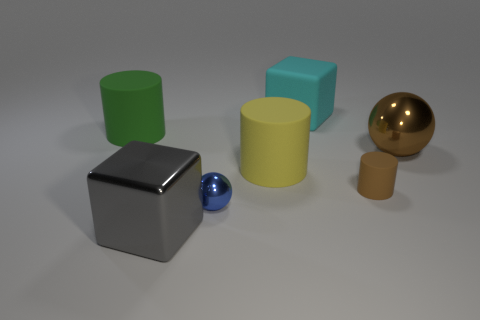Is the number of big cylinders that are in front of the tiny matte thing less than the number of tiny red objects?
Provide a short and direct response. No. Do the tiny matte object and the big shiny sphere have the same color?
Give a very brief answer. Yes. What is the size of the brown matte cylinder?
Offer a terse response. Small. How many large objects have the same color as the small cylinder?
Your answer should be very brief. 1. Are there any rubber cylinders on the right side of the large cylinder in front of the large thing to the left of the large gray metallic block?
Your answer should be very brief. Yes. There is a green rubber thing that is the same size as the brown metallic ball; what shape is it?
Give a very brief answer. Cylinder. What number of large objects are cylinders or brown metal balls?
Provide a succinct answer. 3. There is a large cylinder that is the same material as the big green object; what is its color?
Ensure brevity in your answer.  Yellow. Is the shape of the big rubber object that is left of the big gray metal object the same as the small object right of the blue metallic sphere?
Make the answer very short. Yes. How many metallic things are either yellow objects or big yellow balls?
Ensure brevity in your answer.  0. 